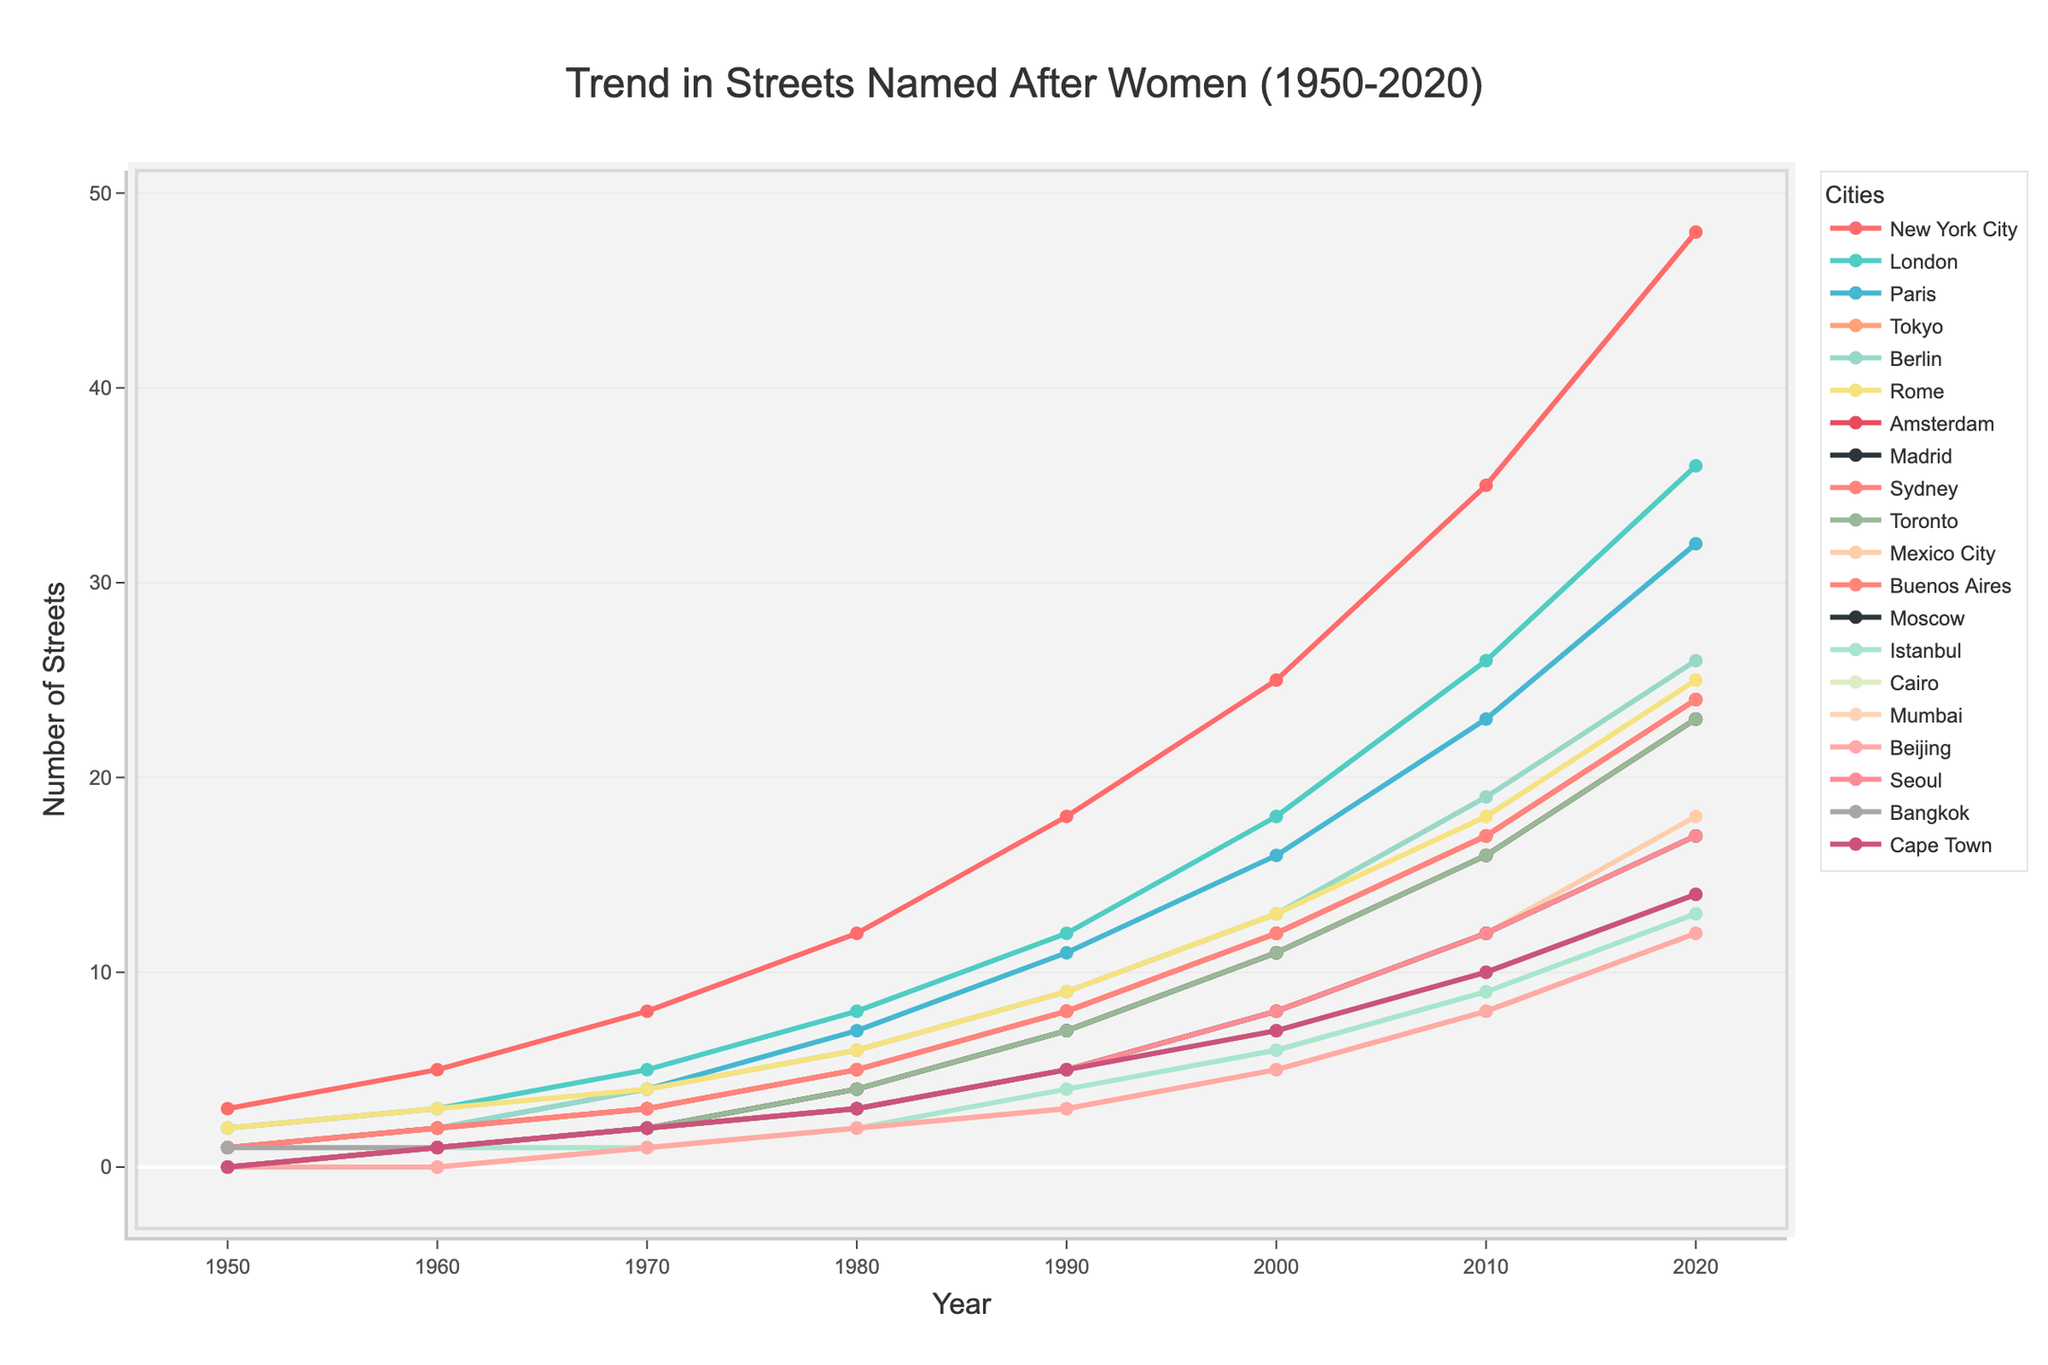Which city had the steepest increase in the number of streets named after women between 1950 and 2020? First, observe the final number of streets for each city in 2020. Then, subtract the initial number of streets in 1950 from this value. The city with the highest difference represents the steepest increase. For New York City: 48 - 3 = 45, for London: 36 - 2 = 34, and so on. From the data, New York City shows the highest increase.
Answer: New York City Which cities had no streets named after women in 1950? Check the data for the year 1950 and identify cities with a value of 0. The cities with 0 are Tokyo, Madrid, Toronto, Moscow, Istanbul, Cairo, Mumbai, Beijing, and Seoul.
Answer: Tokyo, Madrid, Toronto, Moscow, Istanbul, Cairo, Mumbai, Beijing, and Seoul How many cities had more than 20 streets named after women by 2020? Review the data for the year 2020, count the number of cities where the number of streets is greater than 20: New York City (48), London (36), Paris (32), Berlin (26), Rome (25), and Amsterdam (24), Sydney (24), Toronto (23). Total cities: 8.
Answer: 8 What's the average number of streets named after women in 2020 across all cities? Sum the numbers of streets in 2020 for all cities and divide by the number of cities (20). The sum is 399, so the average is 399 / 20 = 19.95.
Answer: 19.95 Which city had the smallest growth in the number of streets named after women between 1950 and 2020? Calculate the growth for each city by subtracting the 1950 value from the 2020 value and find the smallest difference. For example, Cape Town: 14 - 0 = 14, Mumbai: 12 - 0 = 12, etc. The smallest growth is observed in Cairo: 12 - 0 = 12, Beijing: 12 - 0 = 12, Mumbai, Seoul, and Bangkok.
Answer: Cairo, Beijing, Mumbai, Seoul, and Bangkok Compare the number of streets named after women in Berlin and Buenos Aires in 1990. Which city had more and by how many? Check the values for 1990: Berlin had 9 and Buenos Aires had 8 streets named after women. The difference is 9 - 8 = 1. Therefore, Berlin had 1 more street named after women than Buenos Aires in 1990.
Answer: Berlin, 1 What is the median number of streets named after women across all cities in 2020? Arrange the 2020 street numbers in ascending order: [12, 12, 12, 13, 14, 14, 17, 17, 18, 23, 23, 24, 24, 25, 26, 32, 36, 48] and find the median. With 20 cities, the median is the average of the 10th and 11th values: (18+23)/2 = 20.5.
Answer: 20.5 Which city showed a steady increase in the number of streets named after women with no periods of stagnation or decline from 1950 to 2020? Examine the chart for cities with a consistent upward trend without any plateau or decrease. From the data, New York City had a steady increase every decade.
Answer: New York City 